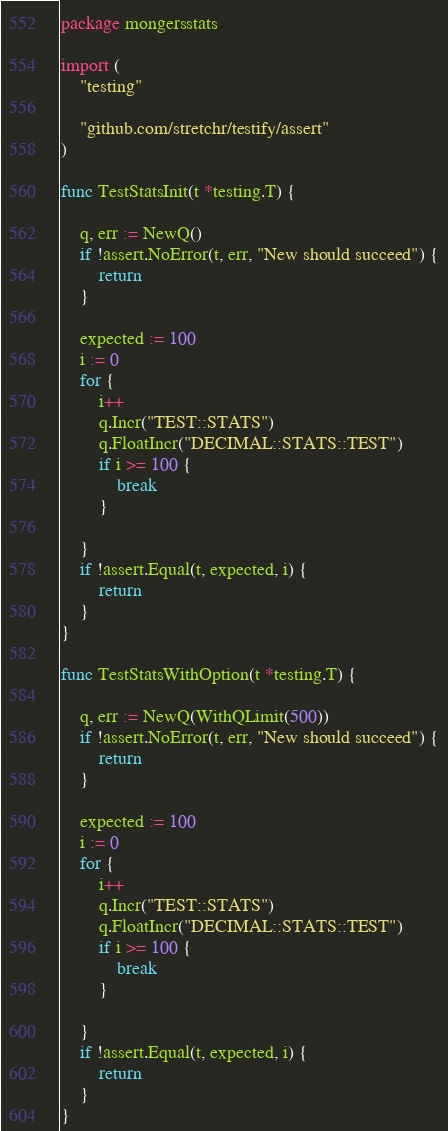<code> <loc_0><loc_0><loc_500><loc_500><_Go_>package mongersstats

import (
	"testing"

	"github.com/stretchr/testify/assert"
)

func TestStatsInit(t *testing.T) {

	q, err := NewQ()
	if !assert.NoError(t, err, "New should succeed") {
		return
	}

	expected := 100
	i := 0
	for {
		i++
		q.Incr("TEST::STATS")
		q.FloatIncr("DECIMAL::STATS::TEST")
		if i >= 100 {
			break
		}

	}
	if !assert.Equal(t, expected, i) {
		return
	}
}

func TestStatsWithOption(t *testing.T) {

	q, err := NewQ(WithQLimit(500))
	if !assert.NoError(t, err, "New should succeed") {
		return
	}

	expected := 100
	i := 0
	for {
		i++
		q.Incr("TEST::STATS")
		q.FloatIncr("DECIMAL::STATS::TEST")
		if i >= 100 {
			break
		}

	}
	if !assert.Equal(t, expected, i) {
		return
	}
}
</code> 